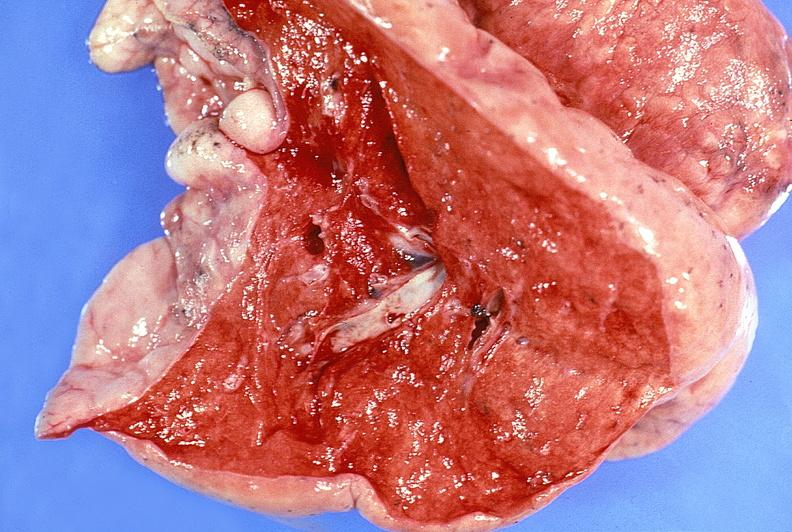where is this?
Answer the question using a single word or phrase. Lung 